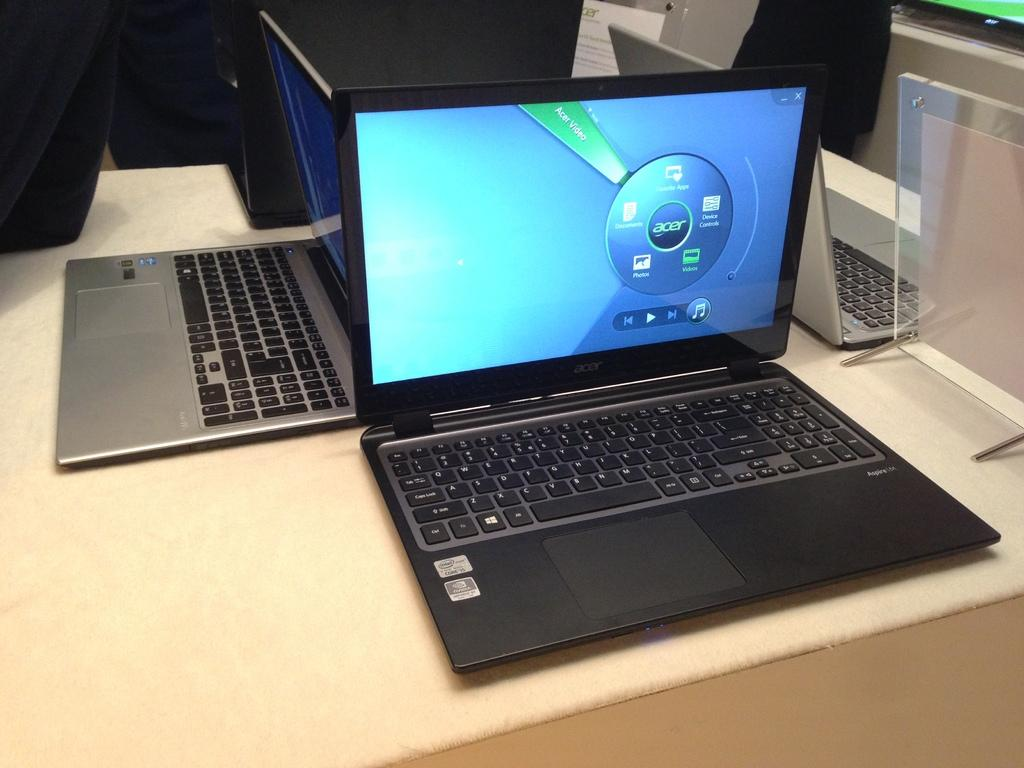<image>
Render a clear and concise summary of the photo. A black laptop with screen that displays an Acer brand 